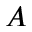Convert formula to latex. <formula><loc_0><loc_0><loc_500><loc_500>A</formula> 